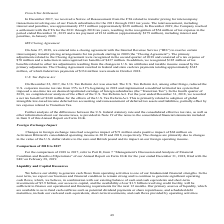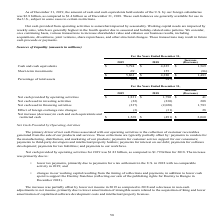According to Activision Blizzard's financial document, What is the cash and cash equivalents in 2019? According to the financial document, 5,794 (in millions). The relevant text states: "Cash and cash equivalents $ 5,794 $ 4,225 $ 1,569..." Also, What is the cash and cash equivalents in 2018? According to the financial document, 4,225 (in millions). The relevant text states: "Cash and cash equivalents $ 5,794 $ 4,225 $ 1,569..." Also, What were the short-term investments in 2019? According to the financial document, 69 (in millions). The relevant text states: "Cash and cash equivalents $ 5,794 $ 4,225 $ 1,569..." Also, can you calculate: What was the percentage change in cash and cash equivalents between 2018 and 2019?  To answer this question, I need to perform calculations using the financial data. The calculation is: ($5,794-$4,225)/$4,225, which equals 37.14 (percentage). This is based on the information: "Cash and cash equivalents $ 5,794 $ 4,225 $ 1,569 Cash and cash equivalents $ 5,794 $ 4,225 $ 1,569..." The key data points involved are: 4,225, 5,794. Also, can you calculate: What was the percentage change in Short-term investments between 2018 and 2019? To answer this question, I need to perform calculations using the financial data. The calculation is: (69-155)/155, which equals -55.48 (percentage). This is based on the information: "Short-term investments 69 155 (86) Short-term investments 69 155 (86)..." The key data points involved are: 155, 69. Also, can you calculate: What percentage of total assets consists of short-term investments in 2019? Based on the calculation: 69/5,863, the result is 1.18 (percentage). This is based on the information: "$ 5,863 $ 4,380 $ 1,483 Short-term investments 69 155 (86)..." The key data points involved are: 5,863, 69. 